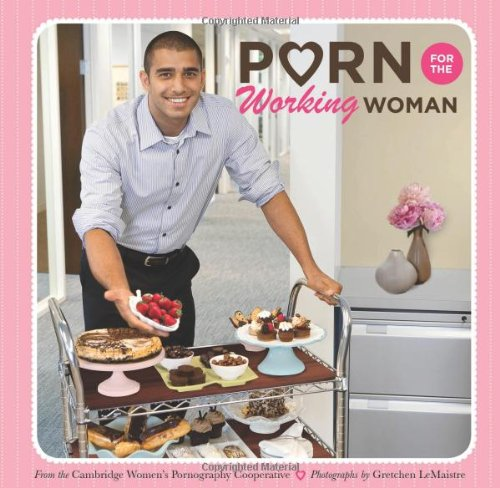Why might the imagery of desserts be significant in this context? The imagery of desserts might symbolize indulgence and reward, aligning with the theme of the book which humorously caters to the idea of treating oneself amidst the daily grind of work life. How does this align with the book’s target audience? The theme of indulgence and reward through delightful desserts is likely to resonate with the target audience—working women, offering them a humorous reprieve from their routine with a visual and thematic treat. 